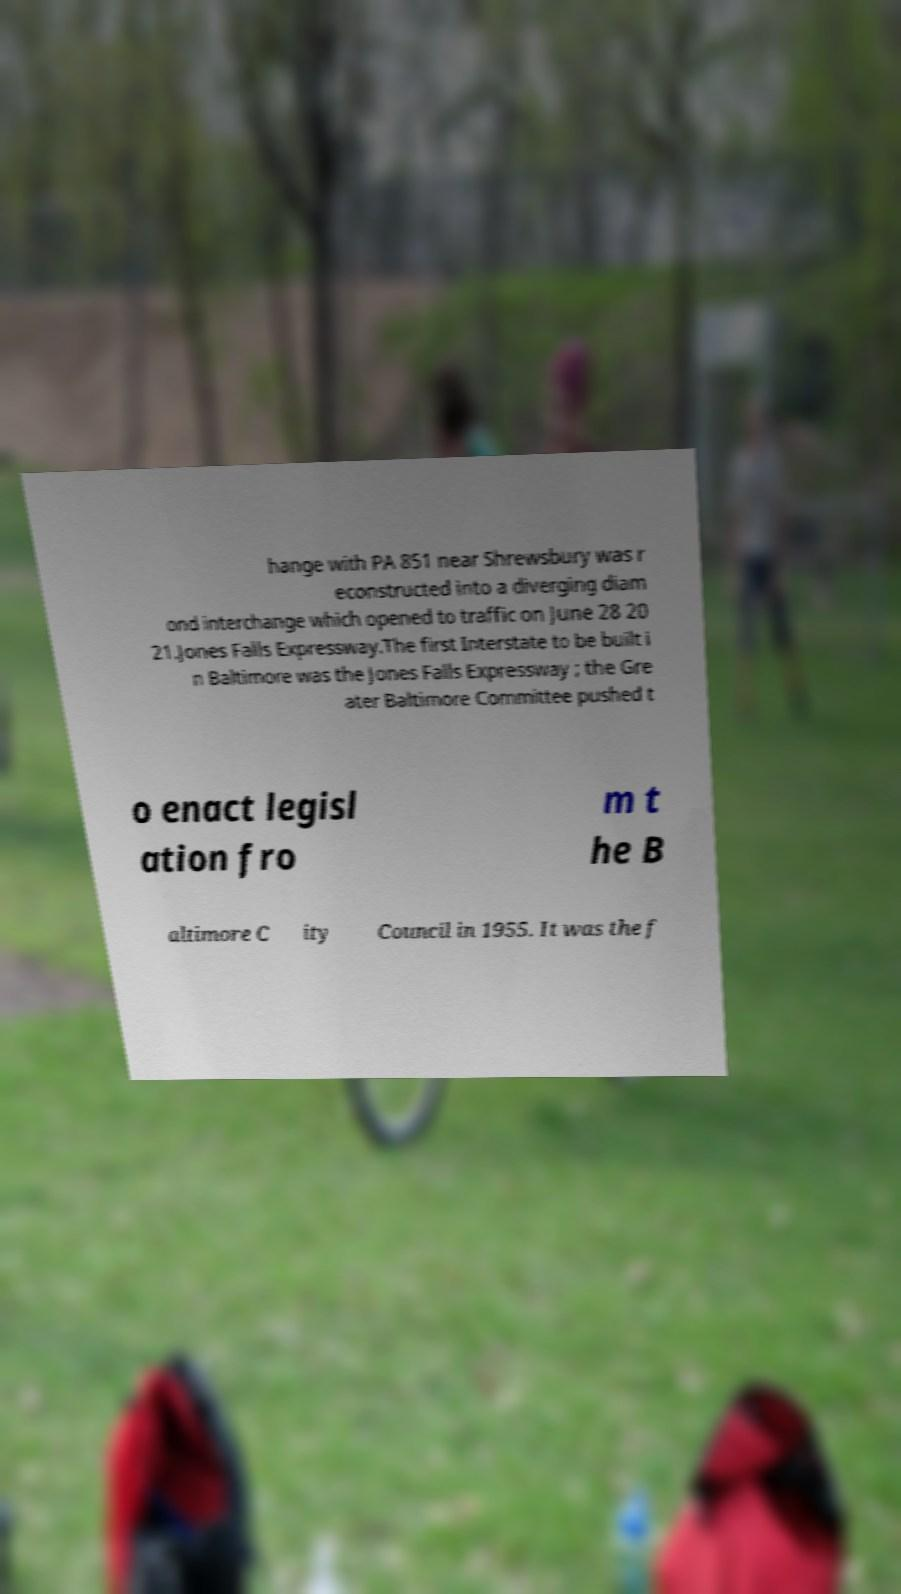Could you extract and type out the text from this image? hange with PA 851 near Shrewsbury was r econstructed into a diverging diam ond interchange which opened to traffic on June 28 20 21.Jones Falls Expressway.The first Interstate to be built i n Baltimore was the Jones Falls Expressway ; the Gre ater Baltimore Committee pushed t o enact legisl ation fro m t he B altimore C ity Council in 1955. It was the f 